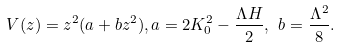Convert formula to latex. <formula><loc_0><loc_0><loc_500><loc_500>V ( z ) = z ^ { 2 } ( a + b z ^ { 2 } ) , a = 2 K _ { 0 } ^ { 2 } - \frac { \Lambda H } { 2 } , \ b = \frac { \Lambda ^ { 2 } } { 8 } .</formula> 